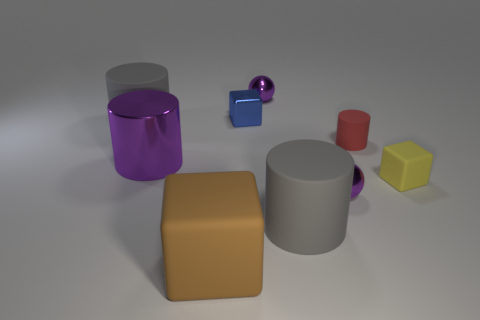Could you imagine what these objects could be used for if they were real? If these objects were real, the cylinders could serve as holders or storage containers, the spheres might be decorative or used in kinetic sculptures, and the cubes could be building blocks or weights for calibration. 